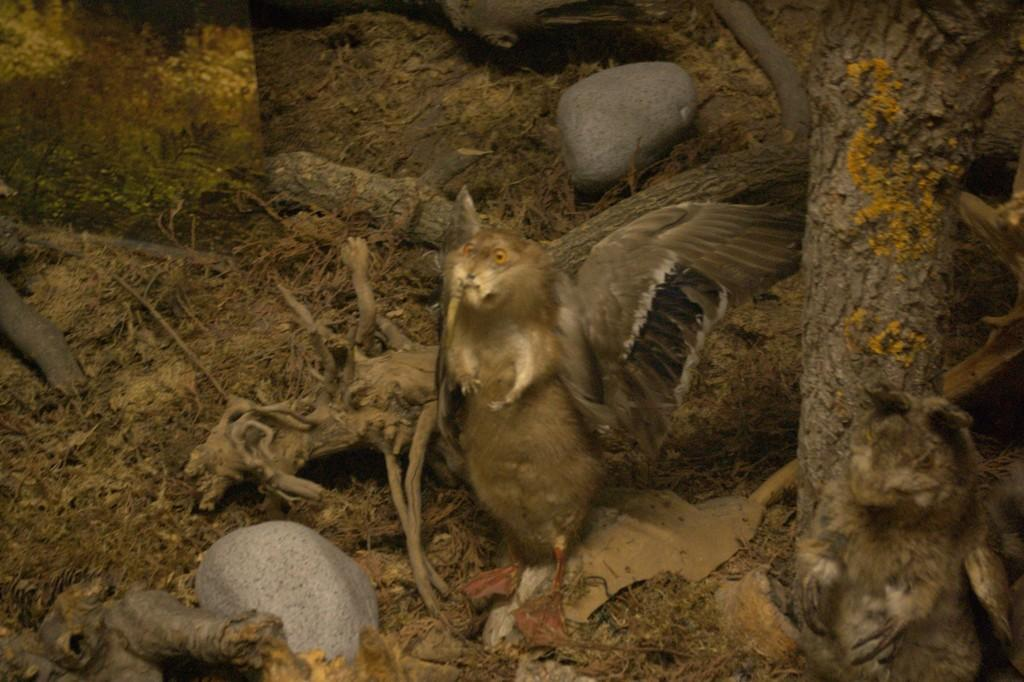What objects are present in the image that resemble long, thin pieces of wood? There are sticks in the image. What type of natural objects can be seen in the image? There are two stones in the image. What type of living creature is visible in the image? There is a bird in the image. On which side of the image is the animal located? The animal is on the right side of the image. What type of fruit can be seen in the image, and where is it located? There are no fruits present in the image. 